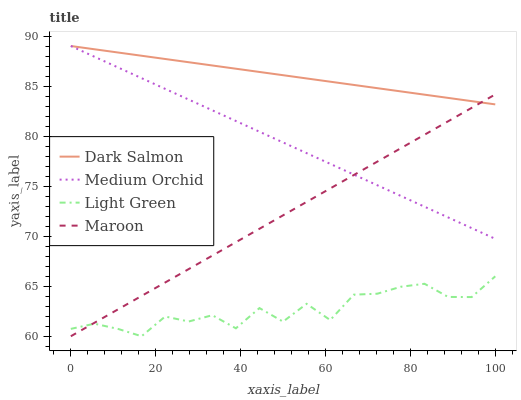Does Light Green have the minimum area under the curve?
Answer yes or no. Yes. Does Dark Salmon have the maximum area under the curve?
Answer yes or no. Yes. Does Medium Orchid have the minimum area under the curve?
Answer yes or no. No. Does Medium Orchid have the maximum area under the curve?
Answer yes or no. No. Is Medium Orchid the smoothest?
Answer yes or no. Yes. Is Light Green the roughest?
Answer yes or no. Yes. Is Dark Salmon the smoothest?
Answer yes or no. No. Is Dark Salmon the roughest?
Answer yes or no. No. Does Maroon have the lowest value?
Answer yes or no. Yes. Does Medium Orchid have the lowest value?
Answer yes or no. No. Does Dark Salmon have the highest value?
Answer yes or no. Yes. Does Light Green have the highest value?
Answer yes or no. No. Is Light Green less than Medium Orchid?
Answer yes or no. Yes. Is Medium Orchid greater than Light Green?
Answer yes or no. Yes. Does Maroon intersect Medium Orchid?
Answer yes or no. Yes. Is Maroon less than Medium Orchid?
Answer yes or no. No. Is Maroon greater than Medium Orchid?
Answer yes or no. No. Does Light Green intersect Medium Orchid?
Answer yes or no. No. 